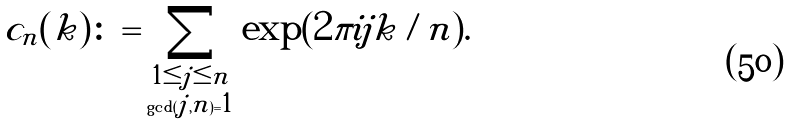<formula> <loc_0><loc_0><loc_500><loc_500>c _ { n } ( k ) \colon = \sum _ { \substack { 1 \leq j \leq n \\ \gcd ( j , n ) = 1 } } \exp ( 2 \pi i j k / n ) .</formula> 